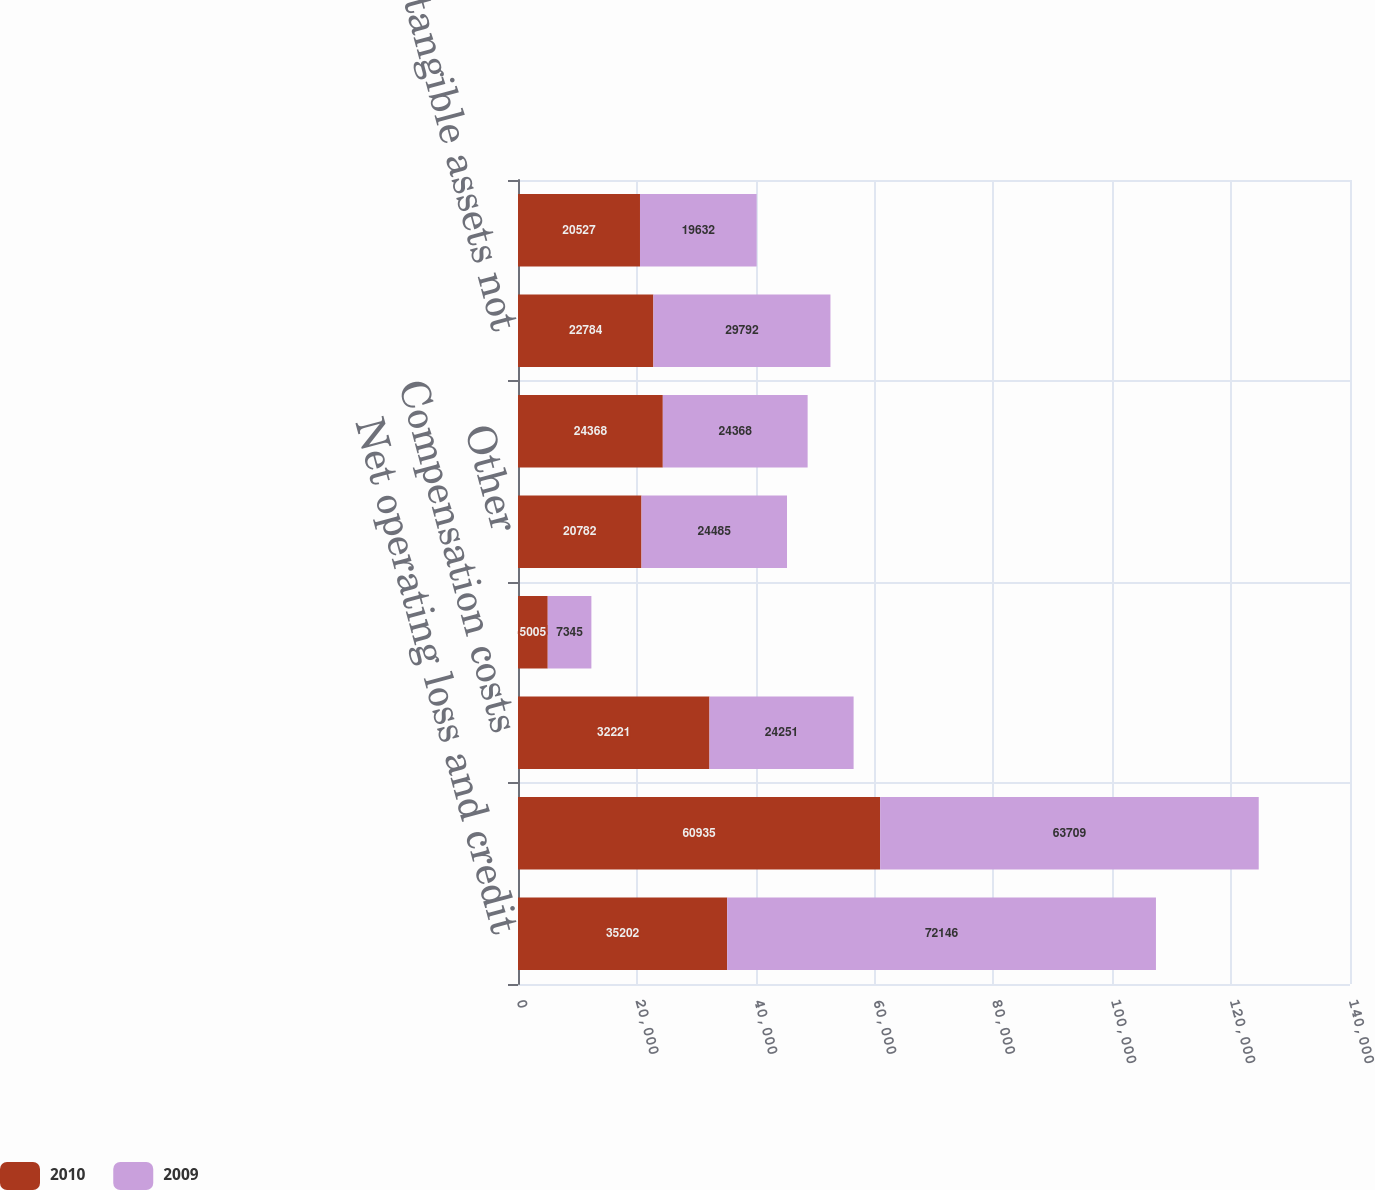<chart> <loc_0><loc_0><loc_500><loc_500><stacked_bar_chart><ecel><fcel>Net operating loss and credit<fcel>Depreciation and amortization<fcel>Compensation costs<fcel>Impairment loss on marketable<fcel>Other<fcel>Deferred tax assets<fcel>Acquired intangible assets not<fcel>Internal-use software<nl><fcel>2010<fcel>35202<fcel>60935<fcel>32221<fcel>5005<fcel>20782<fcel>24368<fcel>22784<fcel>20527<nl><fcel>2009<fcel>72146<fcel>63709<fcel>24251<fcel>7345<fcel>24485<fcel>24368<fcel>29792<fcel>19632<nl></chart> 